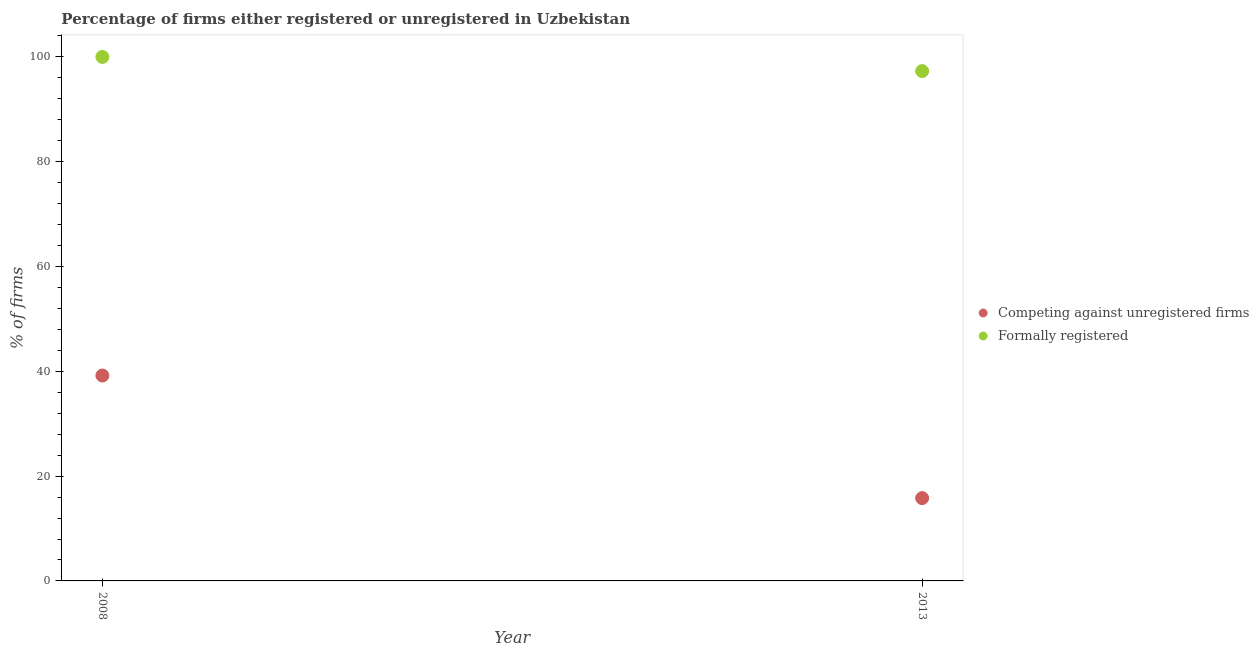How many different coloured dotlines are there?
Make the answer very short. 2. What is the percentage of registered firms in 2008?
Give a very brief answer. 39.2. Across all years, what is the maximum percentage of registered firms?
Give a very brief answer. 39.2. Across all years, what is the minimum percentage of formally registered firms?
Ensure brevity in your answer.  97.3. What is the total percentage of formally registered firms in the graph?
Keep it short and to the point. 197.3. What is the difference between the percentage of registered firms in 2008 and that in 2013?
Offer a terse response. 23.4. What is the difference between the percentage of formally registered firms in 2013 and the percentage of registered firms in 2008?
Ensure brevity in your answer.  58.1. In the year 2008, what is the difference between the percentage of registered firms and percentage of formally registered firms?
Keep it short and to the point. -60.8. In how many years, is the percentage of registered firms greater than 68 %?
Ensure brevity in your answer.  0. What is the ratio of the percentage of formally registered firms in 2008 to that in 2013?
Your answer should be very brief. 1.03. Does the percentage of registered firms monotonically increase over the years?
Give a very brief answer. No. Is the percentage of formally registered firms strictly less than the percentage of registered firms over the years?
Give a very brief answer. No. How many dotlines are there?
Your answer should be very brief. 2. How many years are there in the graph?
Your answer should be compact. 2. How many legend labels are there?
Provide a succinct answer. 2. What is the title of the graph?
Provide a short and direct response. Percentage of firms either registered or unregistered in Uzbekistan. Does "Forest land" appear as one of the legend labels in the graph?
Your response must be concise. No. What is the label or title of the X-axis?
Offer a terse response. Year. What is the label or title of the Y-axis?
Ensure brevity in your answer.  % of firms. What is the % of firms of Competing against unregistered firms in 2008?
Offer a very short reply. 39.2. What is the % of firms in Formally registered in 2008?
Offer a terse response. 100. What is the % of firms in Formally registered in 2013?
Make the answer very short. 97.3. Across all years, what is the maximum % of firms of Competing against unregistered firms?
Provide a succinct answer. 39.2. Across all years, what is the maximum % of firms of Formally registered?
Provide a succinct answer. 100. Across all years, what is the minimum % of firms in Competing against unregistered firms?
Make the answer very short. 15.8. Across all years, what is the minimum % of firms of Formally registered?
Offer a terse response. 97.3. What is the total % of firms of Formally registered in the graph?
Ensure brevity in your answer.  197.3. What is the difference between the % of firms in Competing against unregistered firms in 2008 and that in 2013?
Your answer should be very brief. 23.4. What is the difference between the % of firms in Formally registered in 2008 and that in 2013?
Give a very brief answer. 2.7. What is the difference between the % of firms of Competing against unregistered firms in 2008 and the % of firms of Formally registered in 2013?
Give a very brief answer. -58.1. What is the average % of firms of Competing against unregistered firms per year?
Make the answer very short. 27.5. What is the average % of firms of Formally registered per year?
Your answer should be very brief. 98.65. In the year 2008, what is the difference between the % of firms of Competing against unregistered firms and % of firms of Formally registered?
Make the answer very short. -60.8. In the year 2013, what is the difference between the % of firms in Competing against unregistered firms and % of firms in Formally registered?
Ensure brevity in your answer.  -81.5. What is the ratio of the % of firms of Competing against unregistered firms in 2008 to that in 2013?
Your response must be concise. 2.48. What is the ratio of the % of firms of Formally registered in 2008 to that in 2013?
Ensure brevity in your answer.  1.03. What is the difference between the highest and the second highest % of firms in Competing against unregistered firms?
Offer a terse response. 23.4. What is the difference between the highest and the second highest % of firms of Formally registered?
Make the answer very short. 2.7. What is the difference between the highest and the lowest % of firms of Competing against unregistered firms?
Offer a terse response. 23.4. What is the difference between the highest and the lowest % of firms of Formally registered?
Give a very brief answer. 2.7. 